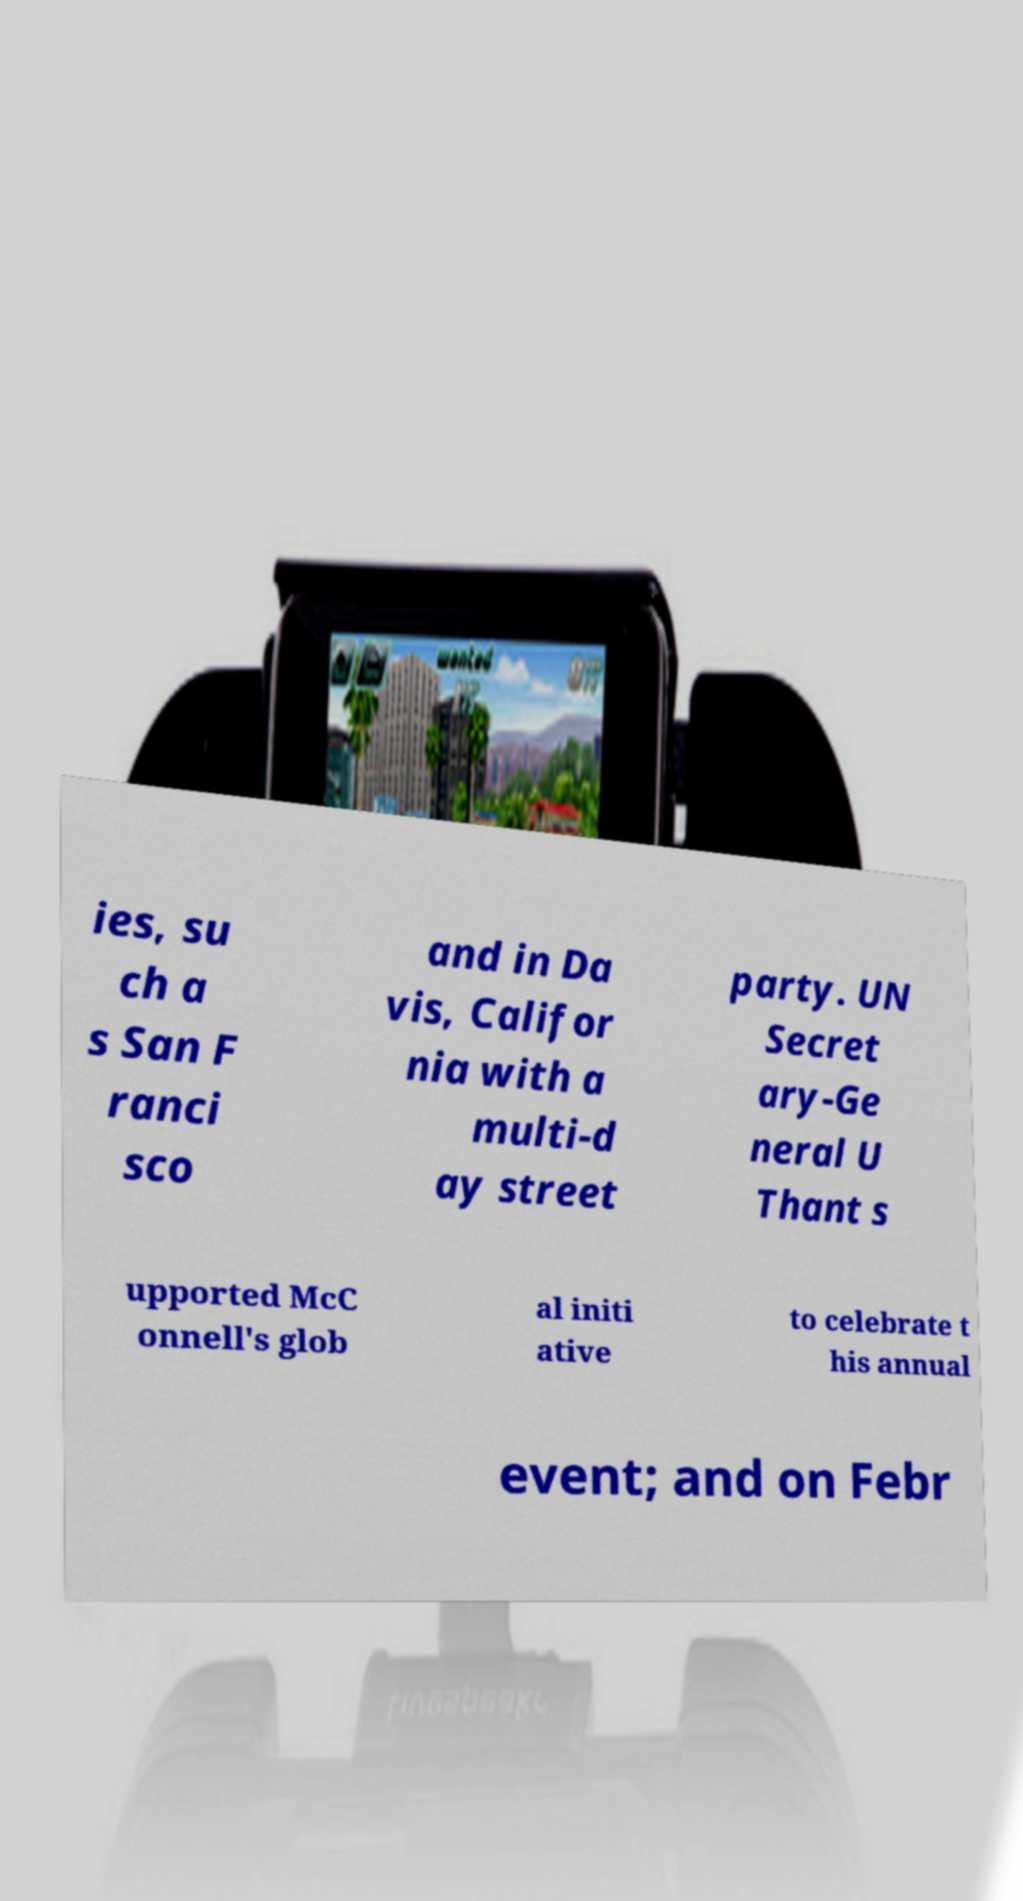There's text embedded in this image that I need extracted. Can you transcribe it verbatim? ies, su ch a s San F ranci sco and in Da vis, Califor nia with a multi-d ay street party. UN Secret ary-Ge neral U Thant s upported McC onnell's glob al initi ative to celebrate t his annual event; and on Febr 